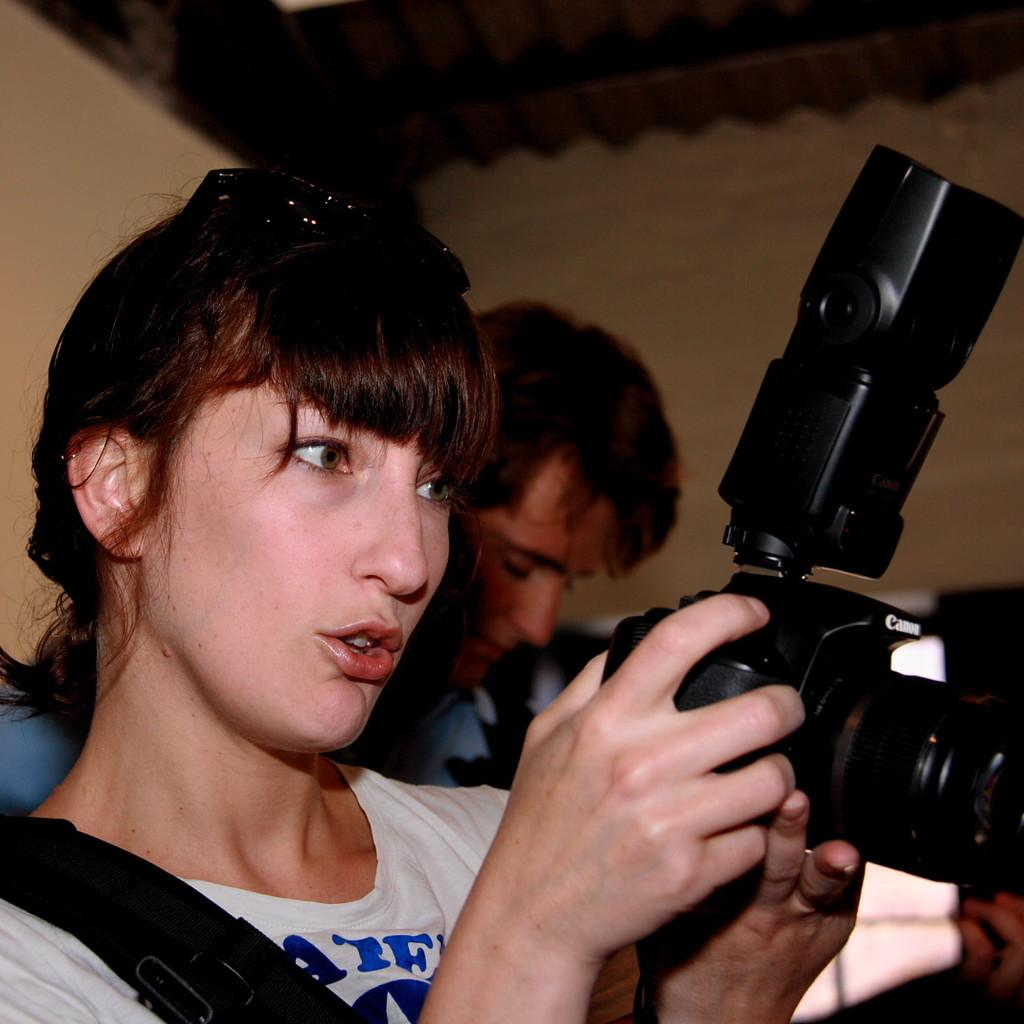What is the person in the image doing? The person is standing in the image. What is the person wearing? The person is wearing a white t-shirt. What is the person holding in her hand? The person is holding a camera in her hand. Can you describe the other person in the image? There is another person standing behind her. What can be seen in the background of the image? There is a wall visible in the background. What type of trouble is the governor facing in the image? There is no governor present in the image, nor is there any indication of trouble. 